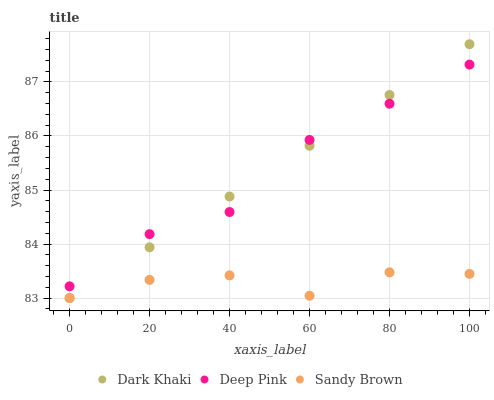Does Sandy Brown have the minimum area under the curve?
Answer yes or no. Yes. Does Dark Khaki have the maximum area under the curve?
Answer yes or no. Yes. Does Deep Pink have the minimum area under the curve?
Answer yes or no. No. Does Deep Pink have the maximum area under the curve?
Answer yes or no. No. Is Dark Khaki the smoothest?
Answer yes or no. Yes. Is Deep Pink the roughest?
Answer yes or no. Yes. Is Sandy Brown the smoothest?
Answer yes or no. No. Is Sandy Brown the roughest?
Answer yes or no. No. Does Dark Khaki have the lowest value?
Answer yes or no. Yes. Does Deep Pink have the lowest value?
Answer yes or no. No. Does Dark Khaki have the highest value?
Answer yes or no. Yes. Does Deep Pink have the highest value?
Answer yes or no. No. Is Sandy Brown less than Deep Pink?
Answer yes or no. Yes. Is Deep Pink greater than Sandy Brown?
Answer yes or no. Yes. Does Sandy Brown intersect Dark Khaki?
Answer yes or no. Yes. Is Sandy Brown less than Dark Khaki?
Answer yes or no. No. Is Sandy Brown greater than Dark Khaki?
Answer yes or no. No. Does Sandy Brown intersect Deep Pink?
Answer yes or no. No. 